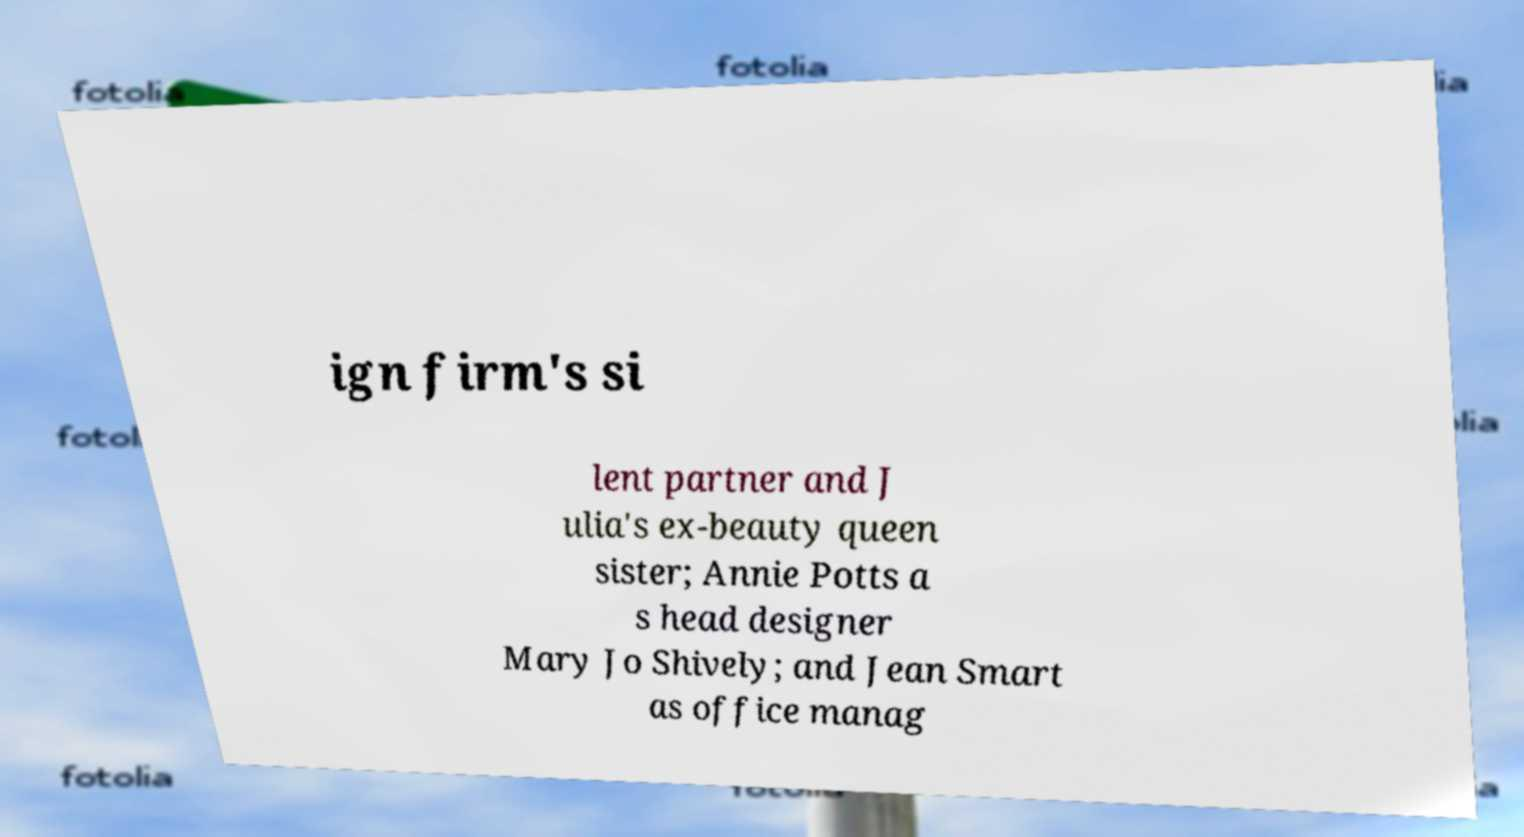I need the written content from this picture converted into text. Can you do that? ign firm's si lent partner and J ulia's ex-beauty queen sister; Annie Potts a s head designer Mary Jo Shively; and Jean Smart as office manag 